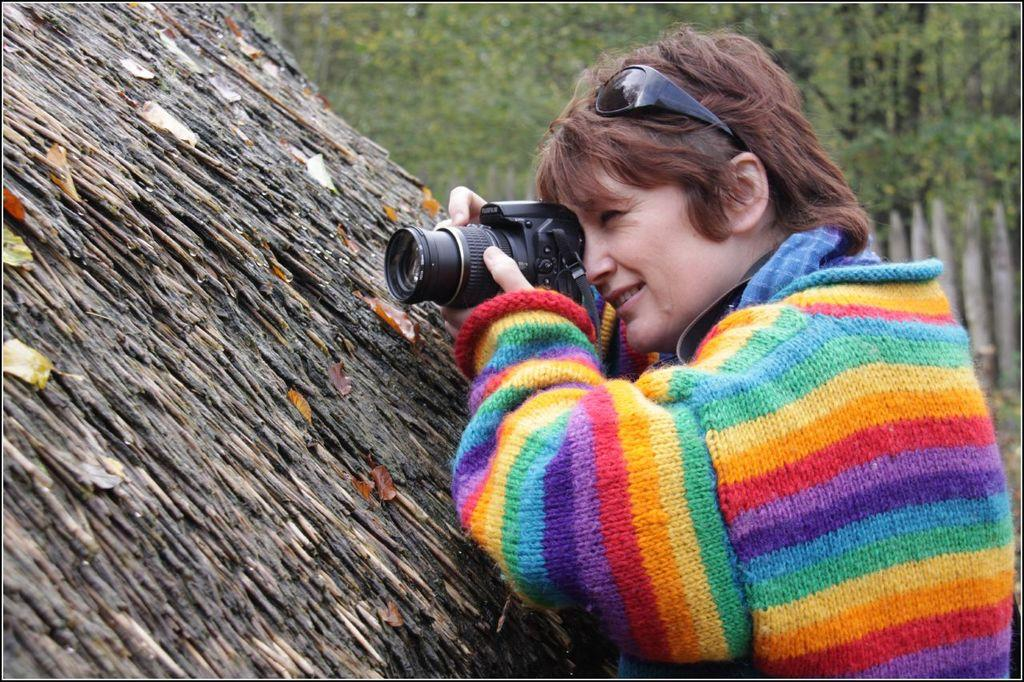Who is the main subject in the image? There is a woman in the image. What is the woman holding in the image? The woman is holding a camera. What is the woman doing with the camera? The woman is taking a picture. What can be seen in the background of the image? There are trees visible behind the woman. What type of farm can be seen in the background of the image? There is no farm present in the image; the background features trees. 